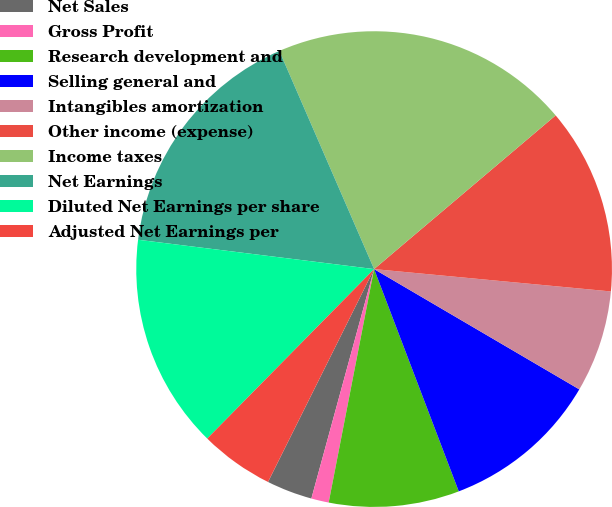<chart> <loc_0><loc_0><loc_500><loc_500><pie_chart><fcel>Net Sales<fcel>Gross Profit<fcel>Research development and<fcel>Selling general and<fcel>Intangibles amortization<fcel>Other income (expense)<fcel>Income taxes<fcel>Net Earnings<fcel>Diluted Net Earnings per share<fcel>Adjusted Net Earnings per<nl><fcel>3.11%<fcel>1.19%<fcel>8.85%<fcel>10.77%<fcel>6.94%<fcel>12.68%<fcel>20.34%<fcel>16.51%<fcel>14.59%<fcel>5.02%<nl></chart> 